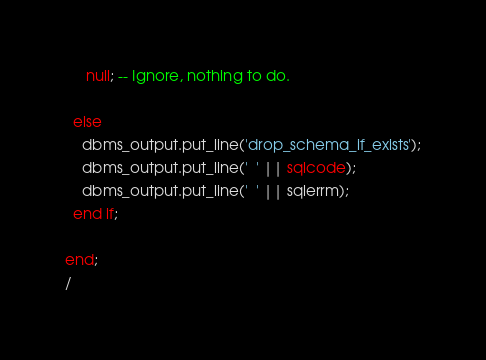<code> <loc_0><loc_0><loc_500><loc_500><_SQL_>     null; -- Ignore, nothing to do.

  else
    dbms_output.put_line('drop_schema_if_exists');
    dbms_output.put_line('  ' || sqlcode);
    dbms_output.put_line('  ' || sqlerrm);
  end if;

end;
/
</code> 